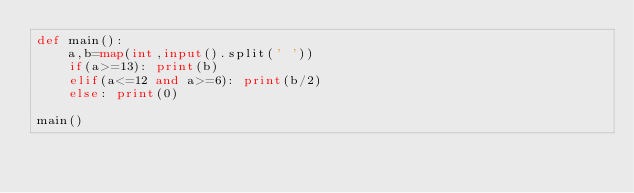<code> <loc_0><loc_0><loc_500><loc_500><_Python_>def main():
    a,b=map(int,input().split(' '))
    if(a>=13): print(b)
    elif(a<=12 and a>=6): print(b/2)
    else: print(0)

main()
</code> 